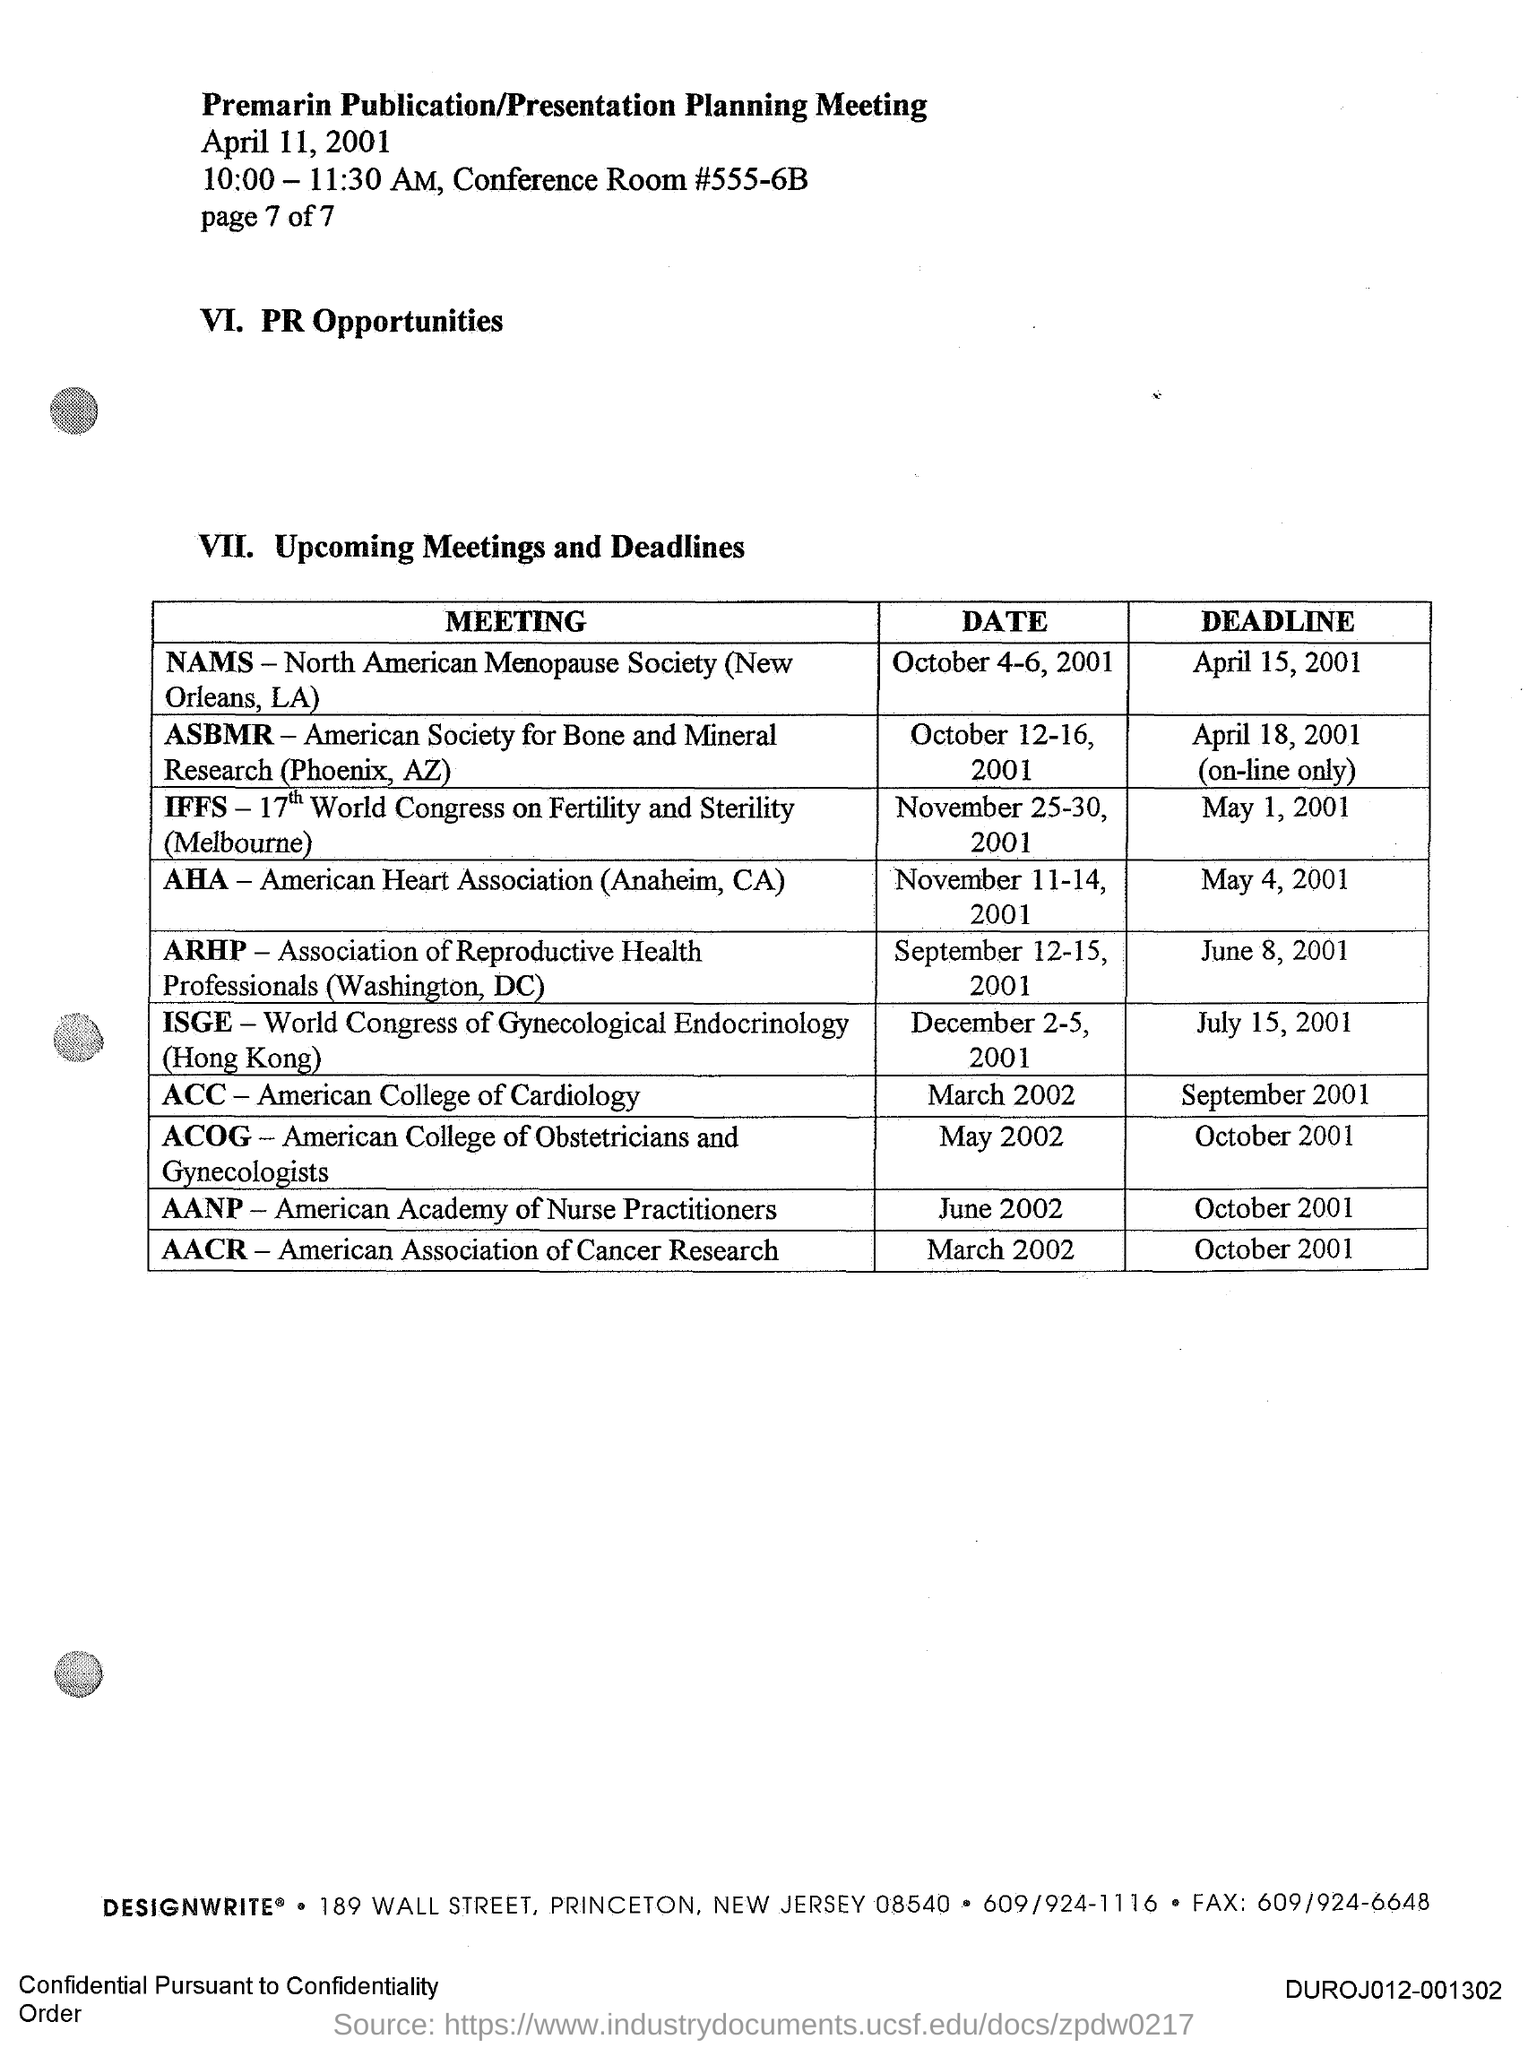What is the Deadline for NAMS Meeting?
Give a very brief answer. April 15, 2001. What is the Deadline for ASBMR Meeting?
Provide a short and direct response. April 18, 2001 (on-line only). What is the Deadline for IFFS Meeting?
Your answer should be very brief. May 1, 2001. What is the Deadline for AHA Meeting?
Give a very brief answer. May 4, 2001. What is the Deadline for ARHP Meeting?
Your answer should be compact. June 8, 2001. What is the Deadline for ISGE Meeting?
Your answer should be very brief. July 15, 2001. What is the Deadline for ACC Meeting?
Offer a terse response. September 2001. What is the Deadline for ACOG Meeting?
Offer a very short reply. October 2001. What is the Deadline for AANP Meeting?
Keep it short and to the point. October 2001. What is the Deadline for AACR Meeting?
Provide a short and direct response. October 2001. 